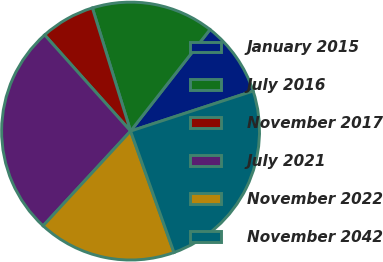Convert chart. <chart><loc_0><loc_0><loc_500><loc_500><pie_chart><fcel>January 2015<fcel>July 2016<fcel>November 2017<fcel>July 2021<fcel>November 2022<fcel>November 2042<nl><fcel>9.41%<fcel>15.35%<fcel>6.82%<fcel>26.53%<fcel>17.33%<fcel>24.56%<nl></chart> 